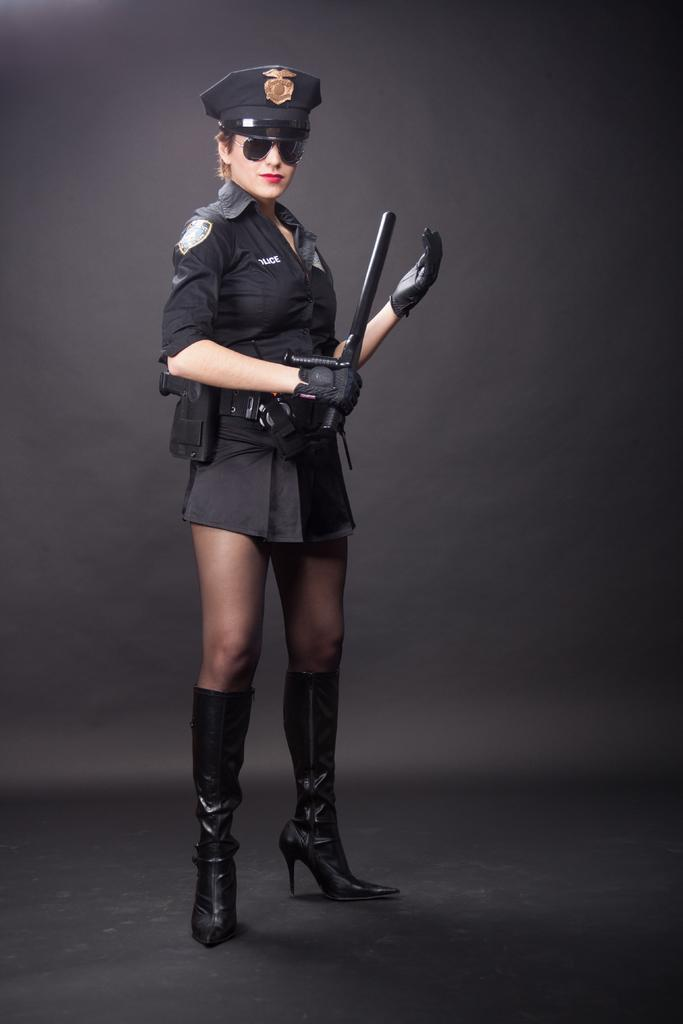Who is present in the image? There is a woman in the image. What is the woman doing in the image? The woman is standing on the floor. What is the woman wearing in the image? The woman is wearing goggles. What object is the woman holding in the image? The woman is holding a gun in her hand. Where is the quiver located in the image? There is no quiver present in the image. What type of oven is visible in the image? There is no oven present in the image. 